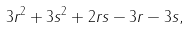Convert formula to latex. <formula><loc_0><loc_0><loc_500><loc_500>3 r ^ { 2 } + 3 s ^ { 2 } + 2 r s - 3 r - 3 s ,</formula> 